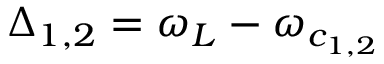Convert formula to latex. <formula><loc_0><loc_0><loc_500><loc_500>\Delta _ { 1 , 2 } = \omega _ { L } - \omega _ { c _ { 1 , 2 } }</formula> 